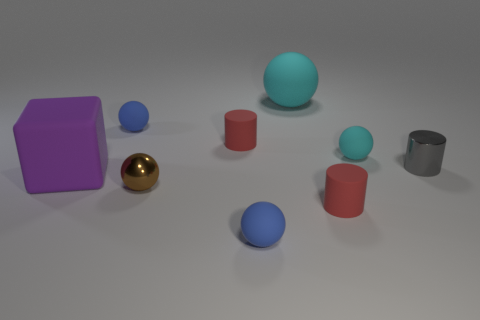What color is the object that is in front of the brown thing and on the right side of the large cyan ball?
Give a very brief answer. Red. Do the large purple cube and the tiny thing to the right of the tiny cyan ball have the same material?
Provide a succinct answer. No. Are there fewer cylinders behind the shiny ball than tiny cylinders?
Make the answer very short. Yes. How many other things are the same shape as the gray thing?
Ensure brevity in your answer.  2. Is there any other thing that is the same color as the large rubber sphere?
Your response must be concise. Yes. There is a big rubber ball; is it the same color as the small matte ball that is to the right of the big cyan matte object?
Ensure brevity in your answer.  Yes. How many other objects are there of the same size as the gray shiny cylinder?
Your answer should be compact. 6. There is a rubber thing that is the same color as the big matte ball; what is its size?
Offer a terse response. Small. How many cubes are purple matte objects or small gray shiny objects?
Ensure brevity in your answer.  1. There is a small brown object that is in front of the large purple matte cube; is it the same shape as the large cyan matte thing?
Provide a short and direct response. Yes. 